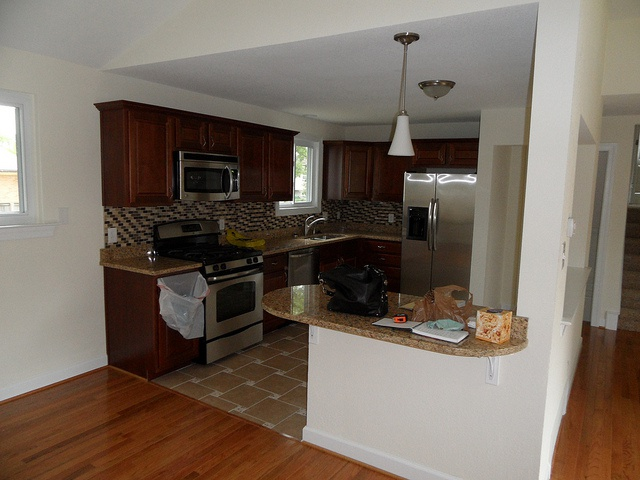Describe the objects in this image and their specific colors. I can see oven in gray and black tones, refrigerator in gray and black tones, microwave in gray and black tones, handbag in gray and black tones, and sink in gray and black tones in this image. 